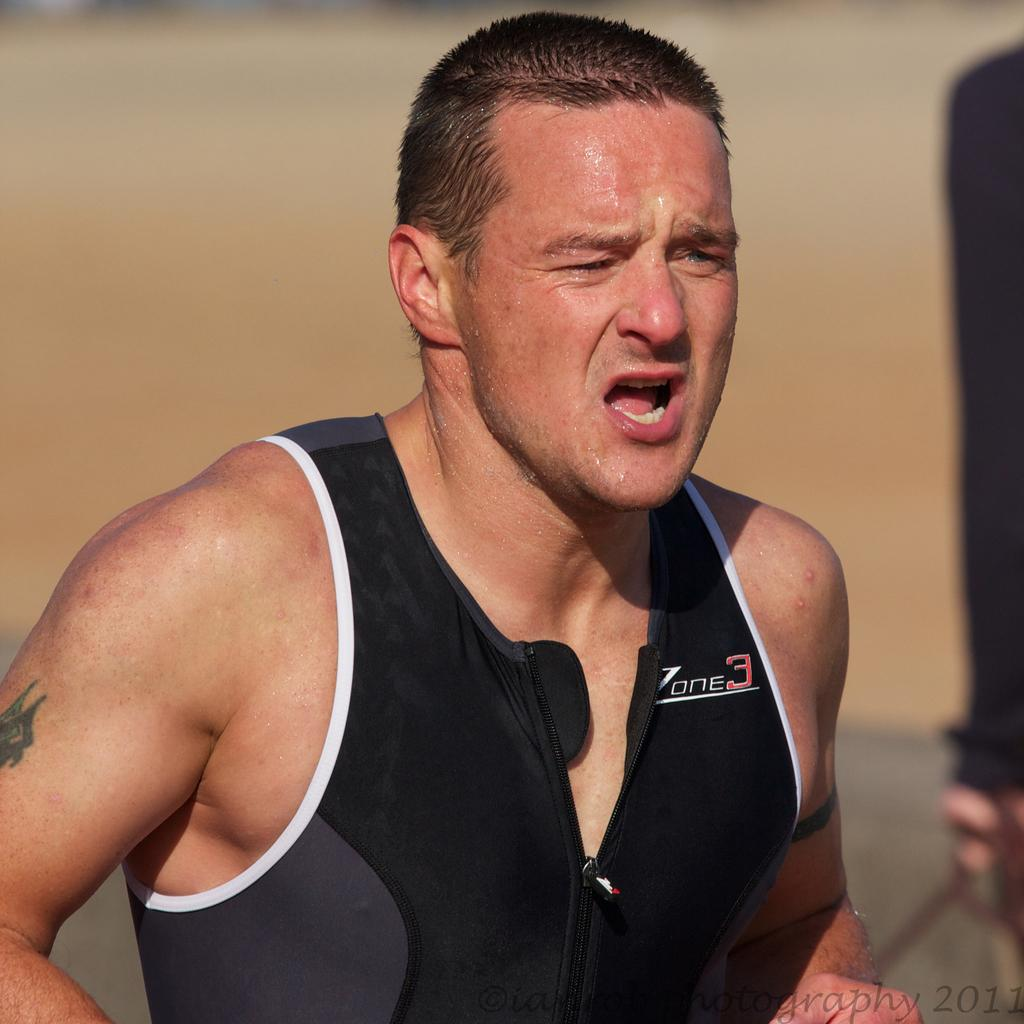Who is the main subject in the image? There is a man in the center of the image. What is the man doing in the image? The man is sweating. What is the man wearing in the image? The man is wearing a black jacket. What type of mitten is the man wearing on his left hand in the image? There is no mitten present in the image; the man is wearing a black jacket. What design can be seen on the man's shirt in the image? There is no information about the man's shirt design in the provided facts, so it cannot be determined from the image. 